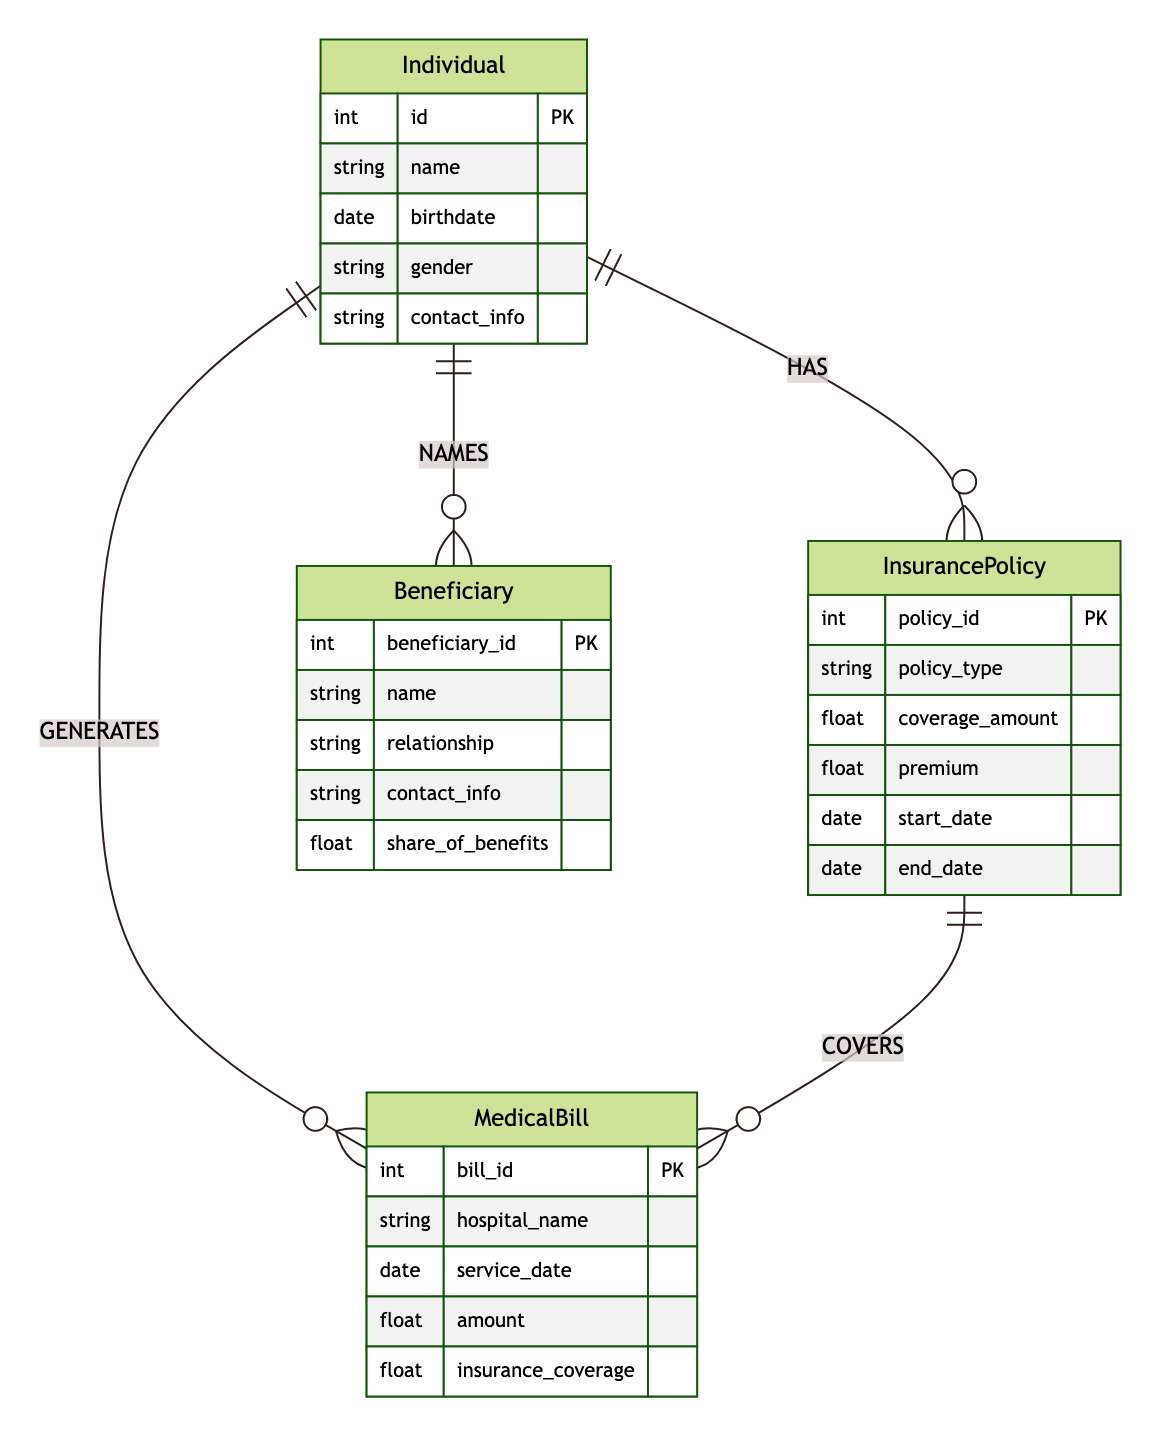What entities are present in the diagram? The diagram contains four entities: Individual, InsurancePolicy, MedicalBill, and Beneficiary. Each entity is represented as a distinct box in the diagram with its own attributes.
Answer: Individual, InsurancePolicy, MedicalBill, Beneficiary How many attributes does the InsurancePolicy entity have? The InsurancePolicy entity includes six attributes, as specified in the diagram. These attributes are policy_id, policy_type, coverage_amount, premium, start_date, and end_date.
Answer: Six What relationship exists between the Individual and InsurancePolicy entities? The diagram shows a relationship labeled "HAS" connecting Individual and InsurancePolicy, indicating that individuals can have one or more insurance policies associated with them.
Answer: HAS How many relationships are there connecting the MedicalBill and InsurancePolicy entities? There is one relationship named "COVERS" that connects the MedicalBill entity to the InsurancePolicy entity, indicating that a policy can cover medical bills.
Answer: One What attribute of the Beneficiary entity indicates their relationship to the Individual? The relationship between the Individual and Beneficiary entities is described through the "relationship" attribute in the Beneficiary entity, specifying how the beneficiary is related to the individual.
Answer: Relationship What type of medical bills does the InsurancePolicy cover? The InsurancePolicy covers MedicalBills, as indicated by the "COVERS" relationship linked to the MedicalBill entity in the diagram.
Answer: MedicalBills How many entities are generating Medical Bills? According to the diagram, the Individual entity is the one that generates MedicalBills, as shown by the "GENERATES" relationship connecting them.
Answer: One Which entity's information can be shared with Beneficiaries? The Individual entity's information can be shared with Beneficiaries, as evidenced by the "NAMES" relationship, which links individuals to their designated beneficiaries.
Answer: Individual 